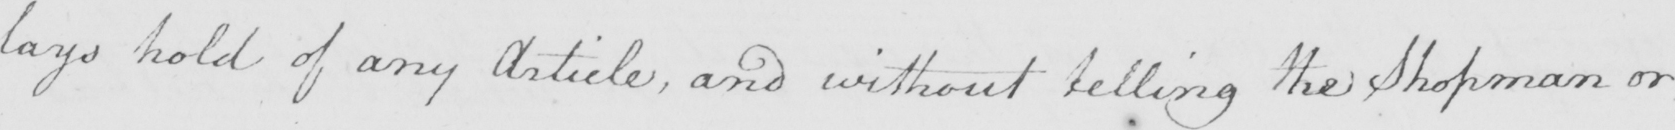Please provide the text content of this handwritten line. lays hold of any Article , and without telling the shopman or 